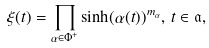<formula> <loc_0><loc_0><loc_500><loc_500>\xi ( t ) = \prod _ { \alpha \in \Phi ^ { + } } \sinh ( \alpha ( t ) ) ^ { m _ { \alpha } } , \, t \in \mathfrak { a } ,</formula> 